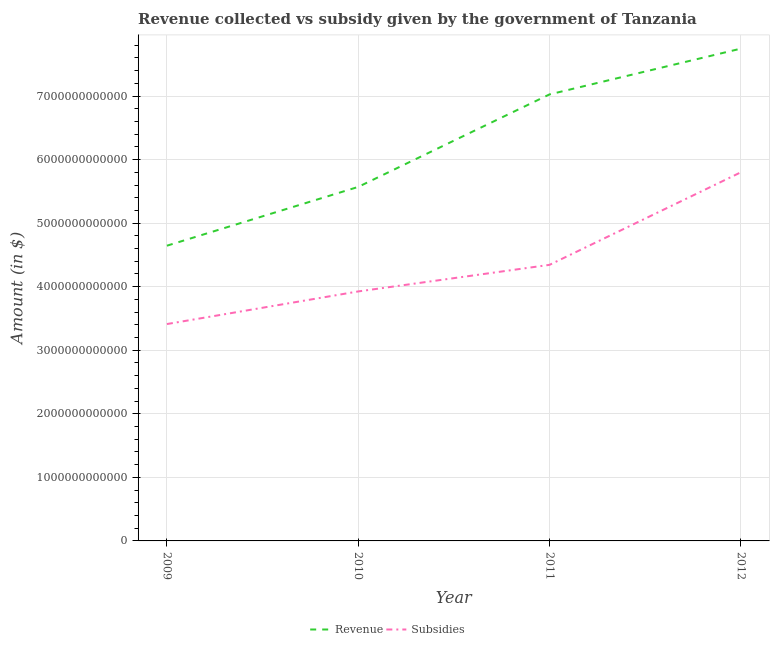How many different coloured lines are there?
Your answer should be very brief. 2. What is the amount of revenue collected in 2012?
Make the answer very short. 7.75e+12. Across all years, what is the maximum amount of subsidies given?
Give a very brief answer. 5.80e+12. Across all years, what is the minimum amount of subsidies given?
Keep it short and to the point. 3.41e+12. In which year was the amount of revenue collected minimum?
Provide a short and direct response. 2009. What is the total amount of revenue collected in the graph?
Give a very brief answer. 2.50e+13. What is the difference between the amount of subsidies given in 2009 and that in 2012?
Make the answer very short. -2.39e+12. What is the difference between the amount of revenue collected in 2011 and the amount of subsidies given in 2009?
Your answer should be compact. 3.61e+12. What is the average amount of revenue collected per year?
Offer a terse response. 6.25e+12. In the year 2010, what is the difference between the amount of revenue collected and amount of subsidies given?
Make the answer very short. 1.64e+12. In how many years, is the amount of revenue collected greater than 4600000000000 $?
Your answer should be compact. 4. What is the ratio of the amount of revenue collected in 2009 to that in 2011?
Your answer should be very brief. 0.66. Is the amount of subsidies given in 2010 less than that in 2011?
Give a very brief answer. Yes. What is the difference between the highest and the second highest amount of revenue collected?
Your answer should be compact. 7.20e+11. What is the difference between the highest and the lowest amount of revenue collected?
Ensure brevity in your answer.  3.10e+12. In how many years, is the amount of revenue collected greater than the average amount of revenue collected taken over all years?
Make the answer very short. 2. Is the sum of the amount of revenue collected in 2009 and 2011 greater than the maximum amount of subsidies given across all years?
Keep it short and to the point. Yes. Does the amount of revenue collected monotonically increase over the years?
Make the answer very short. Yes. What is the difference between two consecutive major ticks on the Y-axis?
Provide a short and direct response. 1.00e+12. Are the values on the major ticks of Y-axis written in scientific E-notation?
Give a very brief answer. No. Does the graph contain any zero values?
Keep it short and to the point. No. How are the legend labels stacked?
Provide a succinct answer. Horizontal. What is the title of the graph?
Make the answer very short. Revenue collected vs subsidy given by the government of Tanzania. Does "Technicians" appear as one of the legend labels in the graph?
Offer a very short reply. No. What is the label or title of the X-axis?
Ensure brevity in your answer.  Year. What is the label or title of the Y-axis?
Offer a very short reply. Amount (in $). What is the Amount (in $) of Revenue in 2009?
Keep it short and to the point. 4.65e+12. What is the Amount (in $) in Subsidies in 2009?
Your answer should be compact. 3.41e+12. What is the Amount (in $) of Revenue in 2010?
Keep it short and to the point. 5.57e+12. What is the Amount (in $) of Subsidies in 2010?
Your response must be concise. 3.93e+12. What is the Amount (in $) of Revenue in 2011?
Offer a very short reply. 7.03e+12. What is the Amount (in $) of Subsidies in 2011?
Your response must be concise. 4.34e+12. What is the Amount (in $) in Revenue in 2012?
Offer a terse response. 7.75e+12. What is the Amount (in $) of Subsidies in 2012?
Give a very brief answer. 5.80e+12. Across all years, what is the maximum Amount (in $) in Revenue?
Provide a short and direct response. 7.75e+12. Across all years, what is the maximum Amount (in $) of Subsidies?
Offer a terse response. 5.80e+12. Across all years, what is the minimum Amount (in $) of Revenue?
Give a very brief answer. 4.65e+12. Across all years, what is the minimum Amount (in $) in Subsidies?
Your response must be concise. 3.41e+12. What is the total Amount (in $) in Revenue in the graph?
Give a very brief answer. 2.50e+13. What is the total Amount (in $) of Subsidies in the graph?
Offer a terse response. 1.75e+13. What is the difference between the Amount (in $) in Revenue in 2009 and that in 2010?
Keep it short and to the point. -9.25e+11. What is the difference between the Amount (in $) of Subsidies in 2009 and that in 2010?
Your response must be concise. -5.13e+11. What is the difference between the Amount (in $) in Revenue in 2009 and that in 2011?
Keep it short and to the point. -2.38e+12. What is the difference between the Amount (in $) of Subsidies in 2009 and that in 2011?
Ensure brevity in your answer.  -9.32e+11. What is the difference between the Amount (in $) of Revenue in 2009 and that in 2012?
Give a very brief answer. -3.10e+12. What is the difference between the Amount (in $) of Subsidies in 2009 and that in 2012?
Offer a very short reply. -2.39e+12. What is the difference between the Amount (in $) in Revenue in 2010 and that in 2011?
Your response must be concise. -1.46e+12. What is the difference between the Amount (in $) of Subsidies in 2010 and that in 2011?
Offer a terse response. -4.18e+11. What is the difference between the Amount (in $) of Revenue in 2010 and that in 2012?
Provide a short and direct response. -2.18e+12. What is the difference between the Amount (in $) of Subsidies in 2010 and that in 2012?
Offer a terse response. -1.87e+12. What is the difference between the Amount (in $) of Revenue in 2011 and that in 2012?
Offer a terse response. -7.20e+11. What is the difference between the Amount (in $) of Subsidies in 2011 and that in 2012?
Offer a very short reply. -1.46e+12. What is the difference between the Amount (in $) of Revenue in 2009 and the Amount (in $) of Subsidies in 2010?
Offer a very short reply. 7.20e+11. What is the difference between the Amount (in $) of Revenue in 2009 and the Amount (in $) of Subsidies in 2011?
Provide a short and direct response. 3.01e+11. What is the difference between the Amount (in $) in Revenue in 2009 and the Amount (in $) in Subsidies in 2012?
Your answer should be very brief. -1.15e+12. What is the difference between the Amount (in $) of Revenue in 2010 and the Amount (in $) of Subsidies in 2011?
Offer a terse response. 1.23e+12. What is the difference between the Amount (in $) of Revenue in 2010 and the Amount (in $) of Subsidies in 2012?
Give a very brief answer. -2.29e+11. What is the difference between the Amount (in $) of Revenue in 2011 and the Amount (in $) of Subsidies in 2012?
Your answer should be compact. 1.23e+12. What is the average Amount (in $) of Revenue per year?
Keep it short and to the point. 6.25e+12. What is the average Amount (in $) of Subsidies per year?
Keep it short and to the point. 4.37e+12. In the year 2009, what is the difference between the Amount (in $) of Revenue and Amount (in $) of Subsidies?
Make the answer very short. 1.23e+12. In the year 2010, what is the difference between the Amount (in $) of Revenue and Amount (in $) of Subsidies?
Offer a terse response. 1.64e+12. In the year 2011, what is the difference between the Amount (in $) of Revenue and Amount (in $) of Subsidies?
Your answer should be compact. 2.68e+12. In the year 2012, what is the difference between the Amount (in $) in Revenue and Amount (in $) in Subsidies?
Make the answer very short. 1.95e+12. What is the ratio of the Amount (in $) of Revenue in 2009 to that in 2010?
Give a very brief answer. 0.83. What is the ratio of the Amount (in $) in Subsidies in 2009 to that in 2010?
Your answer should be very brief. 0.87. What is the ratio of the Amount (in $) of Revenue in 2009 to that in 2011?
Provide a short and direct response. 0.66. What is the ratio of the Amount (in $) in Subsidies in 2009 to that in 2011?
Make the answer very short. 0.79. What is the ratio of the Amount (in $) in Revenue in 2009 to that in 2012?
Offer a terse response. 0.6. What is the ratio of the Amount (in $) in Subsidies in 2009 to that in 2012?
Provide a short and direct response. 0.59. What is the ratio of the Amount (in $) of Revenue in 2010 to that in 2011?
Ensure brevity in your answer.  0.79. What is the ratio of the Amount (in $) of Subsidies in 2010 to that in 2011?
Give a very brief answer. 0.9. What is the ratio of the Amount (in $) of Revenue in 2010 to that in 2012?
Provide a short and direct response. 0.72. What is the ratio of the Amount (in $) in Subsidies in 2010 to that in 2012?
Your answer should be compact. 0.68. What is the ratio of the Amount (in $) in Revenue in 2011 to that in 2012?
Offer a terse response. 0.91. What is the ratio of the Amount (in $) in Subsidies in 2011 to that in 2012?
Your answer should be very brief. 0.75. What is the difference between the highest and the second highest Amount (in $) of Revenue?
Make the answer very short. 7.20e+11. What is the difference between the highest and the second highest Amount (in $) in Subsidies?
Ensure brevity in your answer.  1.46e+12. What is the difference between the highest and the lowest Amount (in $) of Revenue?
Make the answer very short. 3.10e+12. What is the difference between the highest and the lowest Amount (in $) of Subsidies?
Your answer should be compact. 2.39e+12. 